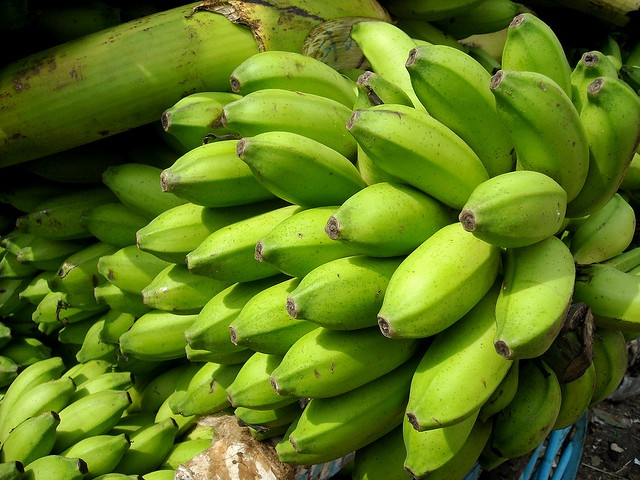Describe the objects in this image and their specific colors. I can see banana in black, darkgreen, and olive tones and banana in black, khaki, olive, and darkgreen tones in this image. 